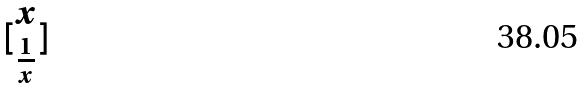Convert formula to latex. <formula><loc_0><loc_0><loc_500><loc_500>[ \begin{matrix} x \\ \frac { 1 } { x } \end{matrix} ]</formula> 